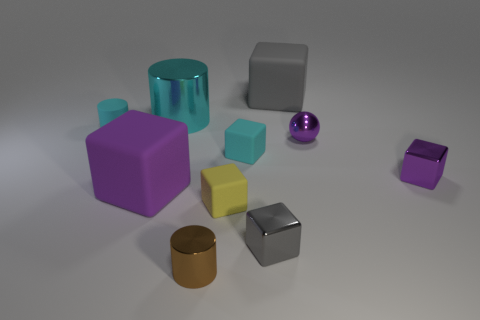Subtract all yellow cubes. How many cubes are left? 5 Subtract all gray cubes. How many cubes are left? 4 Subtract all blue blocks. Subtract all yellow balls. How many blocks are left? 6 Subtract all cylinders. How many objects are left? 7 Subtract 1 cyan cylinders. How many objects are left? 9 Subtract all tiny brown objects. Subtract all tiny metal cylinders. How many objects are left? 8 Add 6 large purple things. How many large purple things are left? 7 Add 5 large cyan shiny cylinders. How many large cyan shiny cylinders exist? 6 